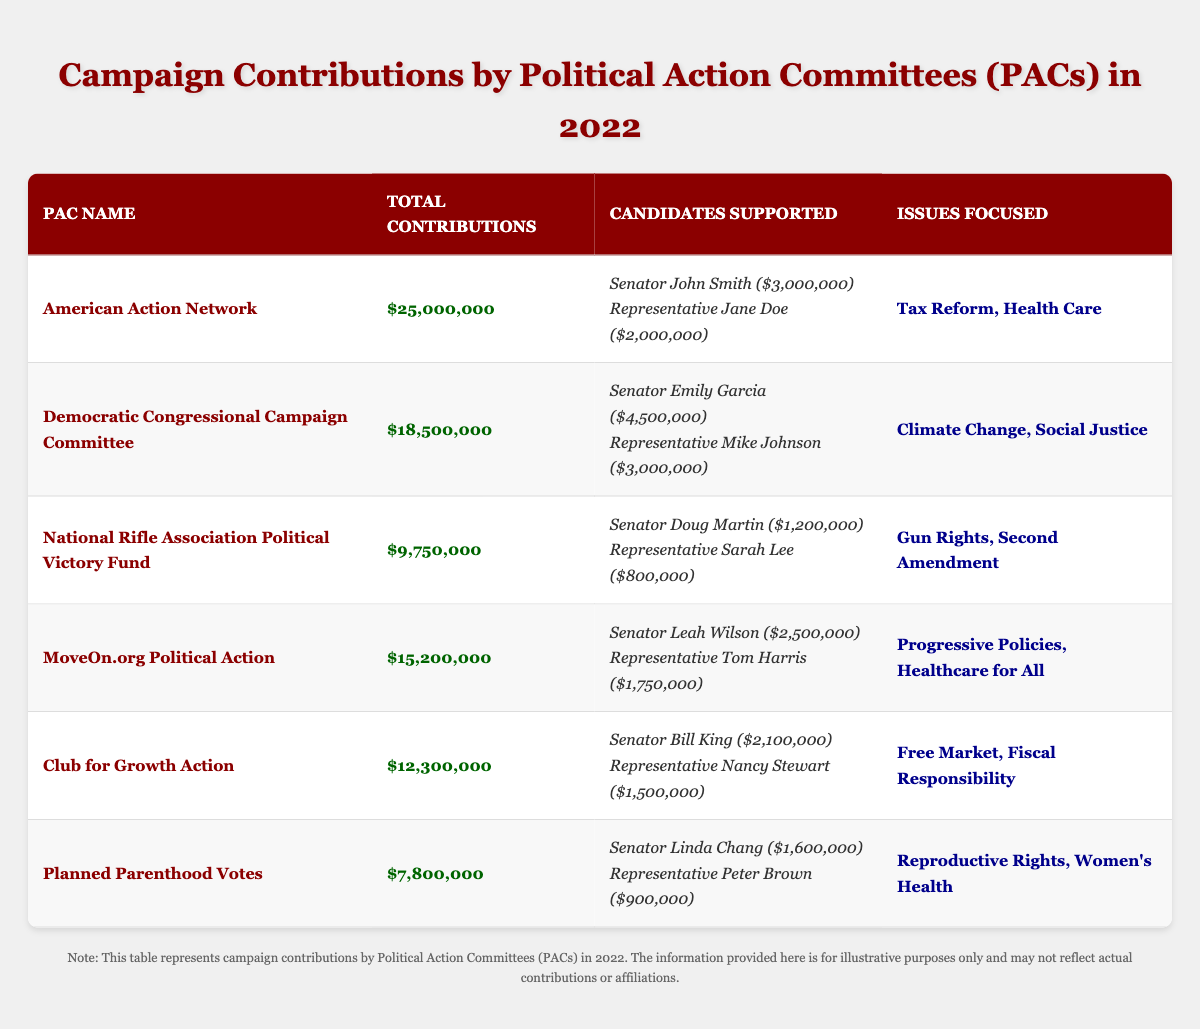What is the total contribution amount from the American Action Network? The total contribution amount listed for the American Action Network is found in the second column of its row in the table. It states "$25,000,000".
Answer: $25,000,000 Which candidate received the highest amount from the Democratic Congressional Campaign Committee? The Democratic Congressional Campaign Committee has two candidates listed, with contribution amounts next to them. Senator Emily Garcia received $4,500,000, which is higher than Representative Mike Johnson's $3,000,000.
Answer: Senator Emily Garcia How much did Planned Parenthood Votes contribute to its top candidate? Planned Parenthood Votes contributed $1,600,000 to Senator Linda Chang, which is listed next to her name in the table.
Answer: $1,600,000 What is the total contribution amount from all the PACs combined? To find the total amount, sum the contributions from all the PACs: $25,000,000 + $18,500,000 + $9,750,000 + $15,200,000 + $12,300,000 + $7,800,000 = $88,550,000.
Answer: $88,550,000 Which PAC contributed the least in total, and what was that amount? Reviewing the total contributions of each PAC, Planned Parenthood Votes has the smallest total contribution of $7,800,000.
Answer: Planned Parenthood Votes; $7,800,000 Did the National Rifle Association Political Victory Fund support any candidates with contributions exceeding $1 million? The National Rifle Association Political Victory Fund supported one candidate, Senator Doug Martin, with a contribution of $1,200,000, which is above $1 million.
Answer: Yes Which two PACs together contributed more than $30 million? Adding up the contributions of American Action Network ($25,000,000) and Democratic Congressional Campaign Committee ($18,500,000) gives a total of $43,500,000, which exceeds $30 million.
Answer: American Action Network and Democratic Congressional Campaign Committee What issues are focused on by the PAC with the second-highest total contributions? The PAC with the second-highest total contributions, Democratic Congressional Campaign Committee, focuses on "Climate Change, Social Justice".
Answer: Climate Change, Social Justice What is the average contribution amount per candidate supported by MoveOn.org Political Action? MoveOn.org Political Action supported 2 candidates. The total contribution to both candidates is $2,500,000 + $1,750,000 = $4,250,000. The average is $4,250,000 divided by 2, which equals $2,125,000.
Answer: $2,125,000 If you combine the contributions from Club for Growth Action and National Rifle Association Political Victory Fund, how much would that be? Adding the contributions gives: $12,300,000 (Club for Growth Action) + $9,750,000 (National Rifle Association Political Victory Fund) = $22,050,000.
Answer: $22,050,000 